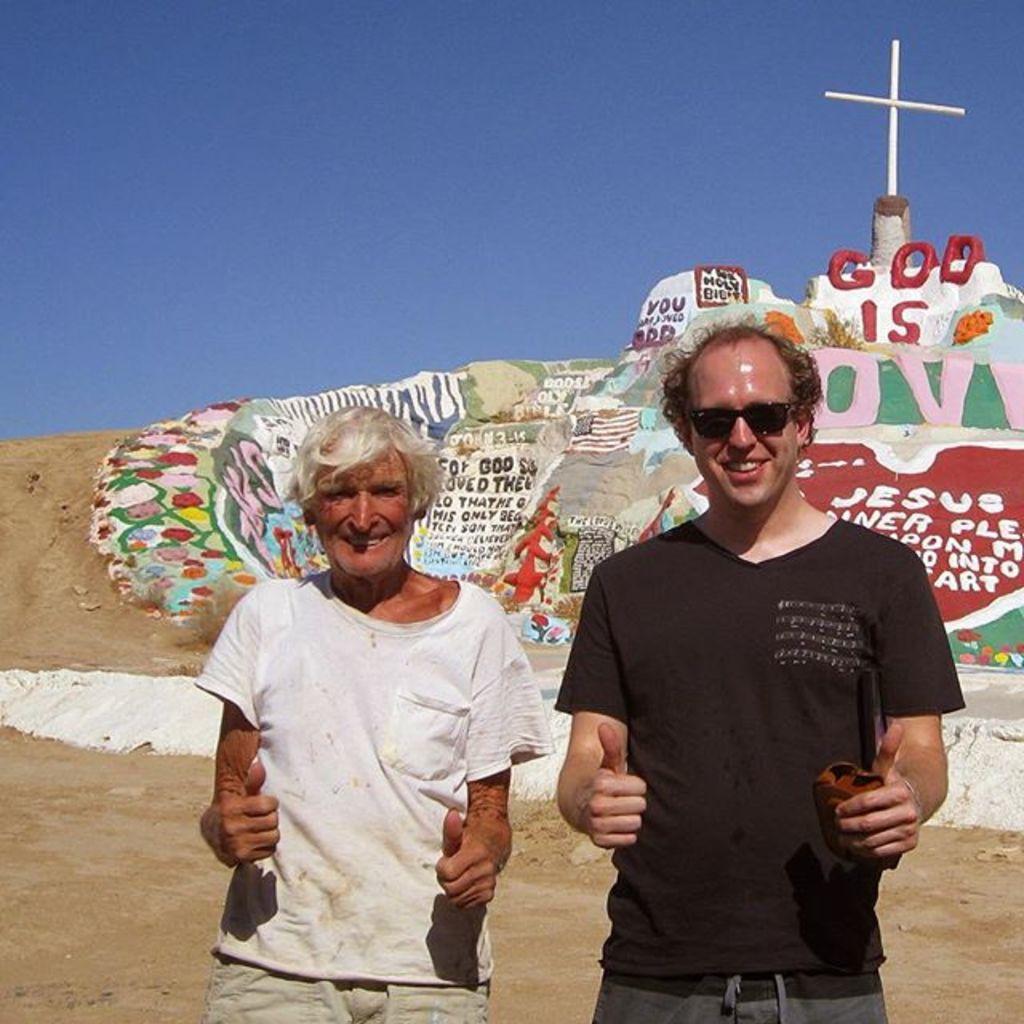In one or two sentences, can you explain what this image depicts? In this picture we can see two people standing and smiling. In the background we can see the ground, cross, paintings, some text and the sky. 